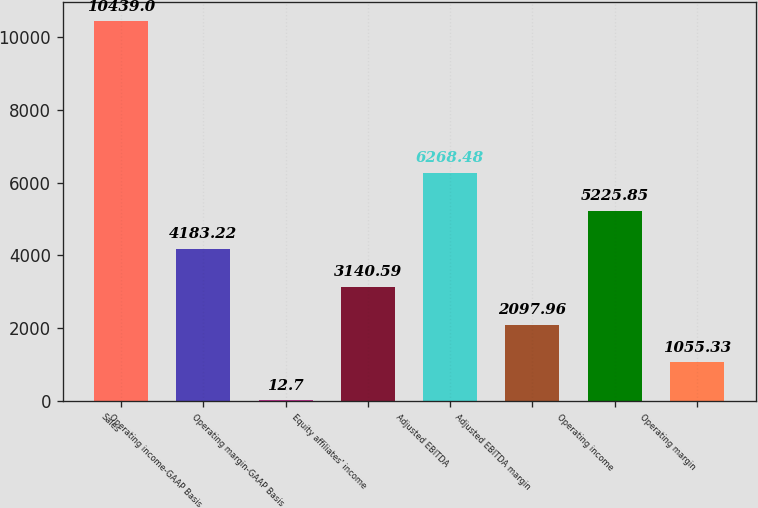<chart> <loc_0><loc_0><loc_500><loc_500><bar_chart><fcel>Sales<fcel>Operating income-GAAP Basis<fcel>Operating margin-GAAP Basis<fcel>Equity affiliates' income<fcel>Adjusted EBITDA<fcel>Adjusted EBITDA margin<fcel>Operating income<fcel>Operating margin<nl><fcel>10439<fcel>4183.22<fcel>12.7<fcel>3140.59<fcel>6268.48<fcel>2097.96<fcel>5225.85<fcel>1055.33<nl></chart> 